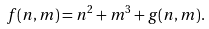<formula> <loc_0><loc_0><loc_500><loc_500>f ( n , m ) = n ^ { 2 } + m ^ { 3 } + g ( n , m ) .</formula> 